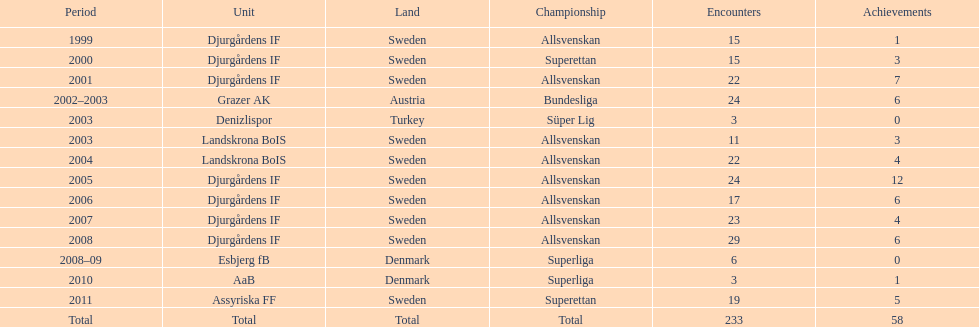What team has the most goals? Djurgårdens IF. Help me parse the entirety of this table. {'header': ['Period', 'Unit', 'Land', 'Championship', 'Encounters', 'Achievements'], 'rows': [['1999', 'Djurgårdens IF', 'Sweden', 'Allsvenskan', '15', '1'], ['2000', 'Djurgårdens IF', 'Sweden', 'Superettan', '15', '3'], ['2001', 'Djurgårdens IF', 'Sweden', 'Allsvenskan', '22', '7'], ['2002–2003', 'Grazer AK', 'Austria', 'Bundesliga', '24', '6'], ['2003', 'Denizlispor', 'Turkey', 'Süper Lig', '3', '0'], ['2003', 'Landskrona BoIS', 'Sweden', 'Allsvenskan', '11', '3'], ['2004', 'Landskrona BoIS', 'Sweden', 'Allsvenskan', '22', '4'], ['2005', 'Djurgårdens IF', 'Sweden', 'Allsvenskan', '24', '12'], ['2006', 'Djurgårdens IF', 'Sweden', 'Allsvenskan', '17', '6'], ['2007', 'Djurgårdens IF', 'Sweden', 'Allsvenskan', '23', '4'], ['2008', 'Djurgårdens IF', 'Sweden', 'Allsvenskan', '29', '6'], ['2008–09', 'Esbjerg fB', 'Denmark', 'Superliga', '6', '0'], ['2010', 'AaB', 'Denmark', 'Superliga', '3', '1'], ['2011', 'Assyriska FF', 'Sweden', 'Superettan', '19', '5'], ['Total', 'Total', 'Total', 'Total', '233', '58']]} 